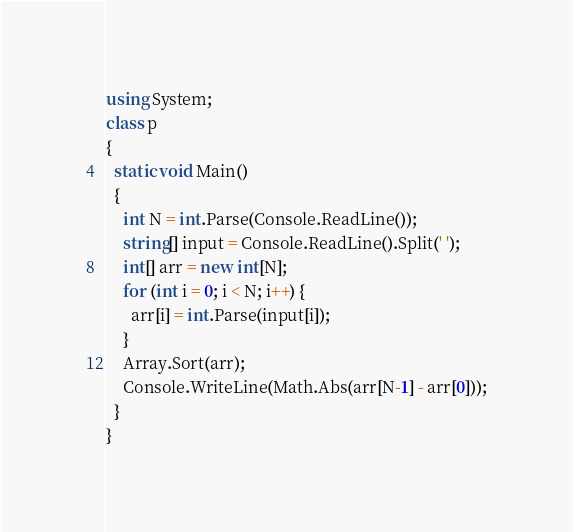<code> <loc_0><loc_0><loc_500><loc_500><_C#_>using System;
class p
{
  static void Main()
  {
    int N = int.Parse(Console.ReadLine());
    string[] input = Console.ReadLine().Split(' ');
    int[] arr = new int[N];
    for (int i = 0; i < N; i++) {
      arr[i] = int.Parse(input[i]);
    }
    Array.Sort(arr);
    Console.WriteLine(Math.Abs(arr[N-1] - arr[0]));
  }
}</code> 